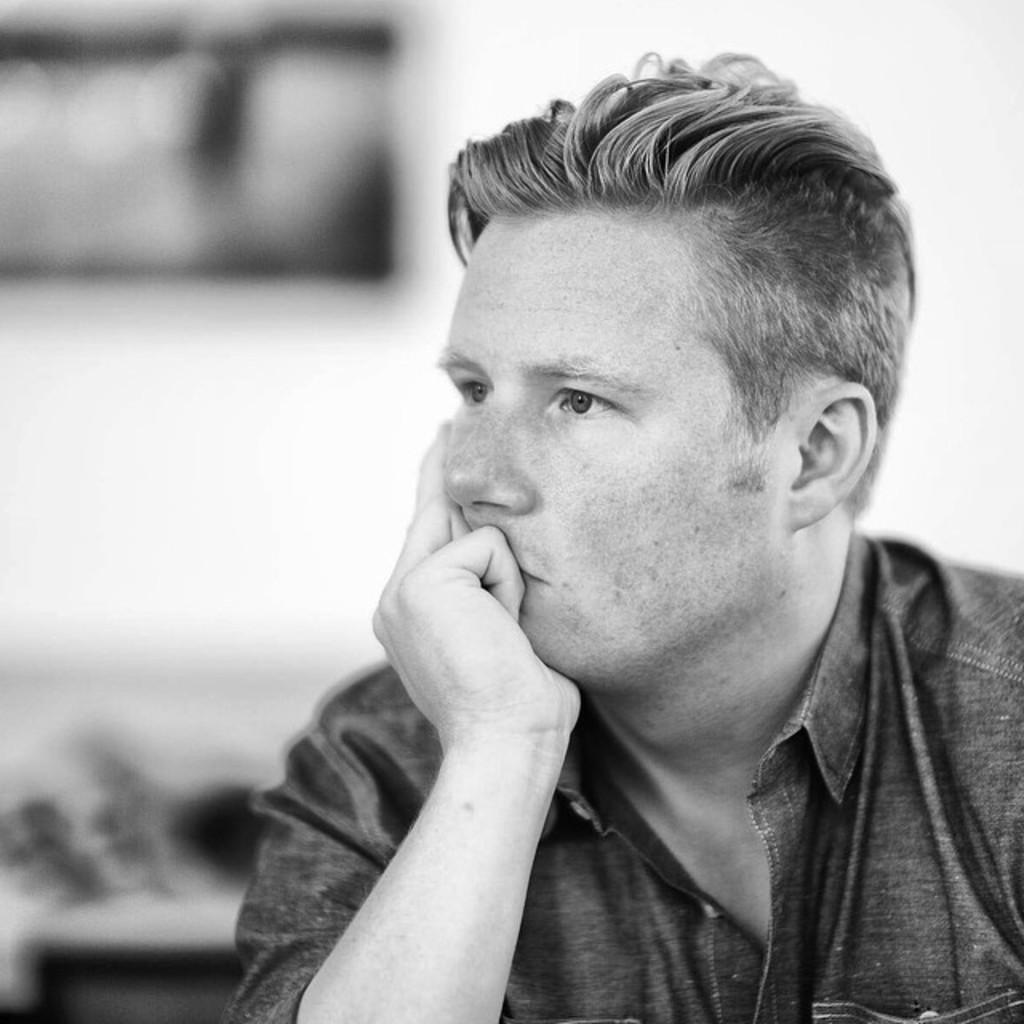What is the color scheme of the image? The image is black and white. Can you describe the main subject in the image? There is a person in the image. Where is the person located in the image? The person is in the middle of the image. What is the person doing in the image? The person is sitting. How many legs does the form have in the image? There is no form present in the image, and therefore no legs can be counted. 